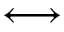Convert formula to latex. <formula><loc_0><loc_0><loc_500><loc_500>\longleftrightarrow</formula> 